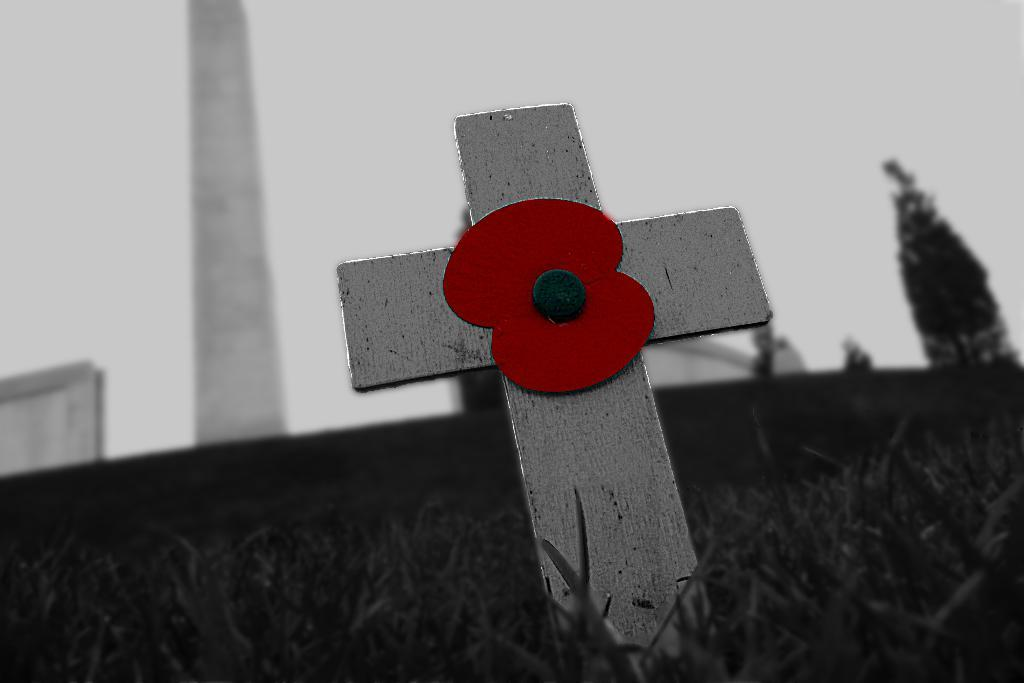What type of vegetation can be seen in the image? There is grass in the image. What is located in the grass? There is a pole in the grass. What colors are present on the pole? The pole has black, red, and ash colors. What can be seen in the background of the image? There is a tree and other objects visible in the background. What is visible in the sky in the background of the image? The sky is visible in the background of the image. How does the toad use the credit card to start the flame in the image? There is no toad, credit card, or flame present in the image. 